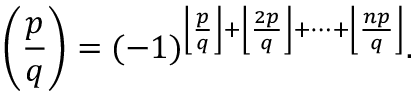Convert formula to latex. <formula><loc_0><loc_0><loc_500><loc_500>\left ( { \frac { p } { q } } \right ) = ( - 1 ) ^ { \left \lfloor { \frac { p } { q } } \right \rfloor + \left \lfloor { \frac { 2 p } { q } } \right \rfloor + \dots + \left \lfloor { \frac { n p } { q } } \right \rfloor } .</formula> 